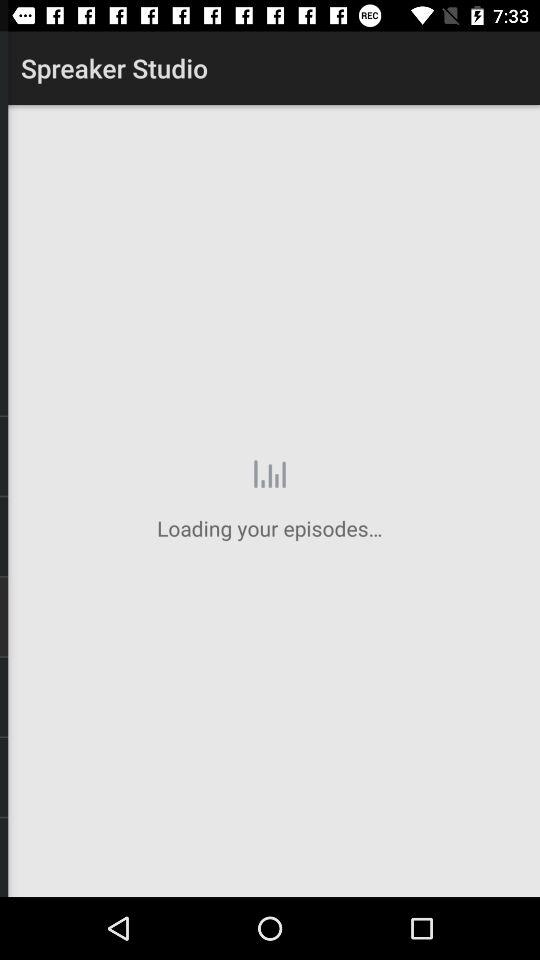Through what application can we log in? You can log in through "Facebook". 